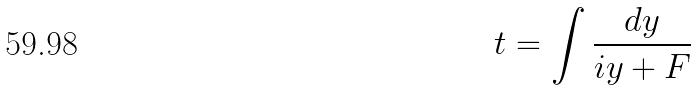Convert formula to latex. <formula><loc_0><loc_0><loc_500><loc_500>t = \int \frac { d y } { i y + F }</formula> 